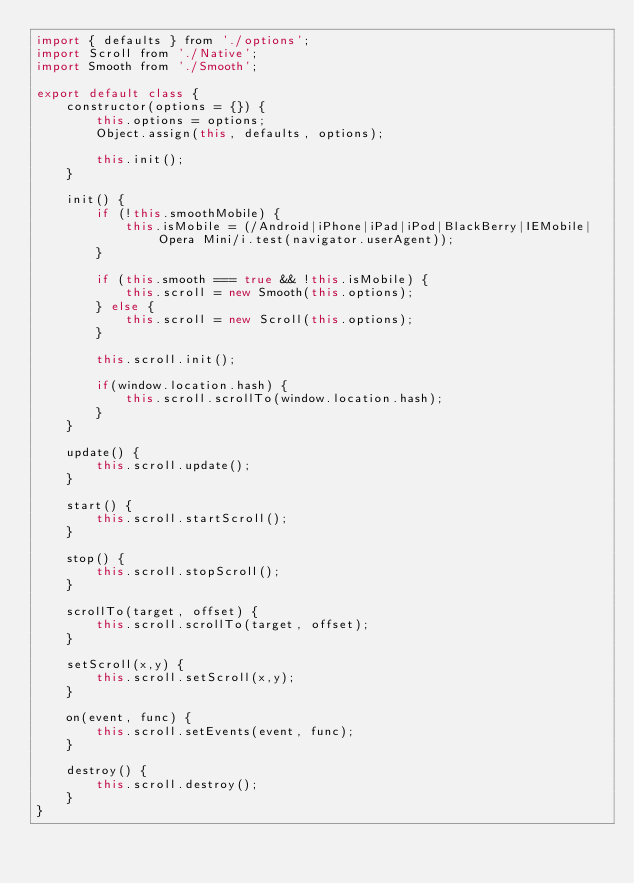Convert code to text. <code><loc_0><loc_0><loc_500><loc_500><_JavaScript_>import { defaults } from './options';
import Scroll from './Native';
import Smooth from './Smooth';

export default class {
    constructor(options = {}) {
        this.options = options;
        Object.assign(this, defaults, options);

        this.init();
    }

    init() {
        if (!this.smoothMobile) {
            this.isMobile = (/Android|iPhone|iPad|iPod|BlackBerry|IEMobile|Opera Mini/i.test(navigator.userAgent));
        }

        if (this.smooth === true && !this.isMobile) {
            this.scroll = new Smooth(this.options);
        } else {
            this.scroll = new Scroll(this.options);
        }

        this.scroll.init();

        if(window.location.hash) {
            this.scroll.scrollTo(window.location.hash);
        }
    }

    update() {
        this.scroll.update();
    }

    start() {
        this.scroll.startScroll();
    }

    stop() {
        this.scroll.stopScroll();
    }

    scrollTo(target, offset) {
        this.scroll.scrollTo(target, offset);
    }

    setScroll(x,y) {
        this.scroll.setScroll(x,y);
    }

    on(event, func) {
        this.scroll.setEvents(event, func);
    }

    destroy() {
        this.scroll.destroy();
    }
}
</code> 